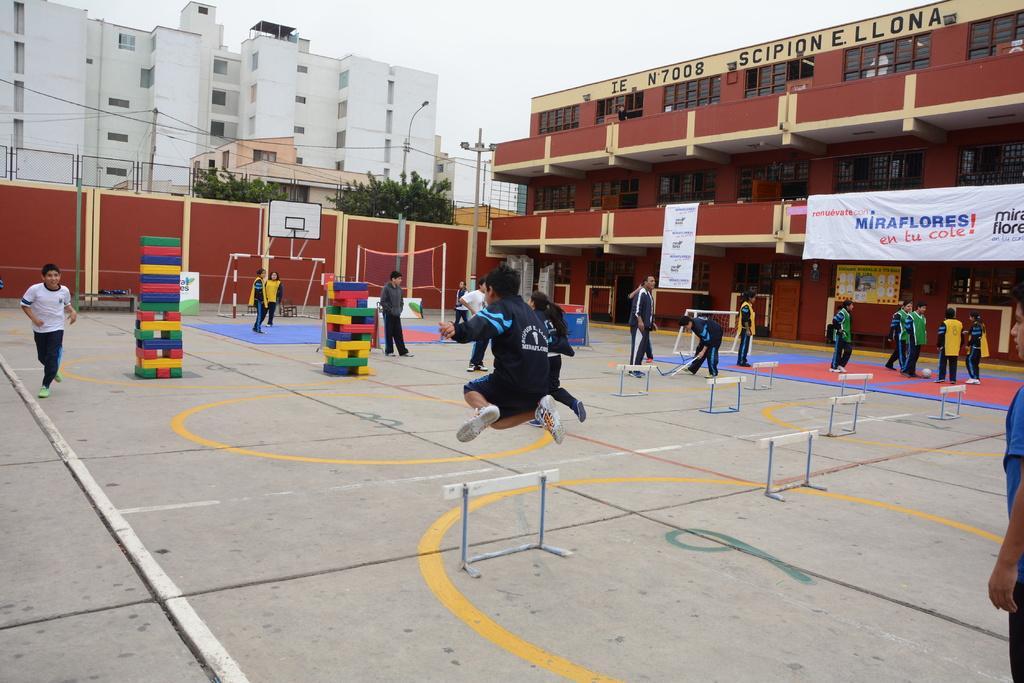Please provide a concise description of this image. In this image I can see a person wearing black dress is jumping in the air. In the background I can see few other persons standing on the ground, few objects which are very colorful, the net, the wall which is maroon and cream in color and the building which is red and cream in color. I can see a white colored banner to the building. I can see few trees, few buildings, few wires, few poles and the sky. 